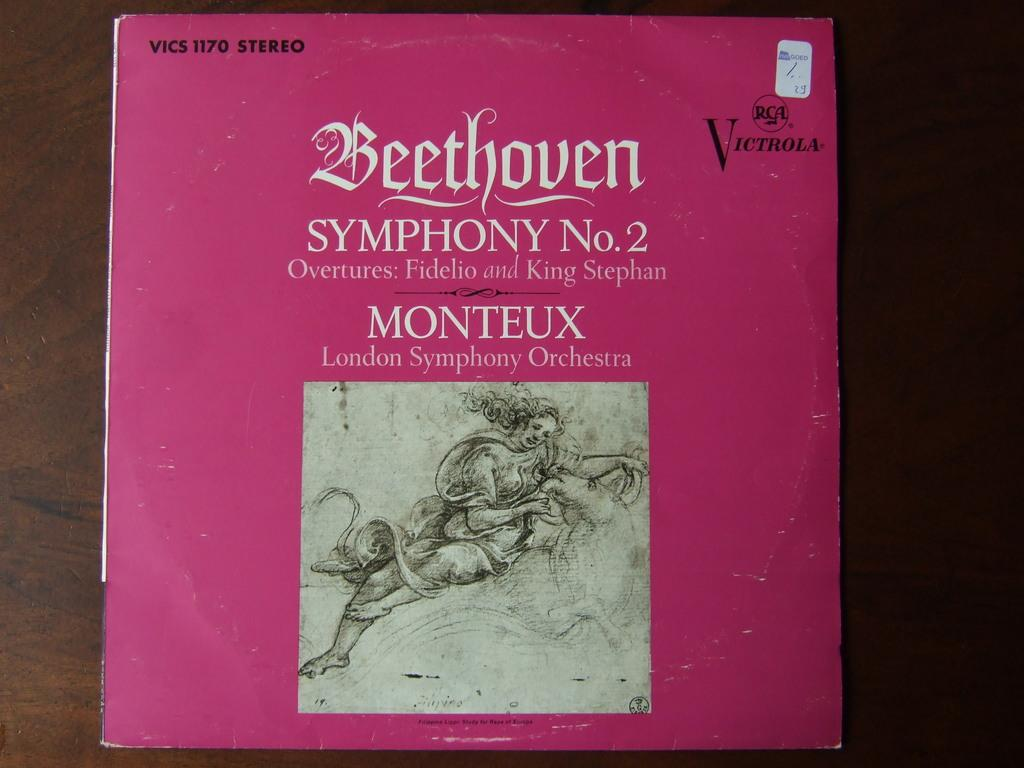<image>
Describe the image concisely. Beethoven's Symphony Numer 2 pink record album cover. 